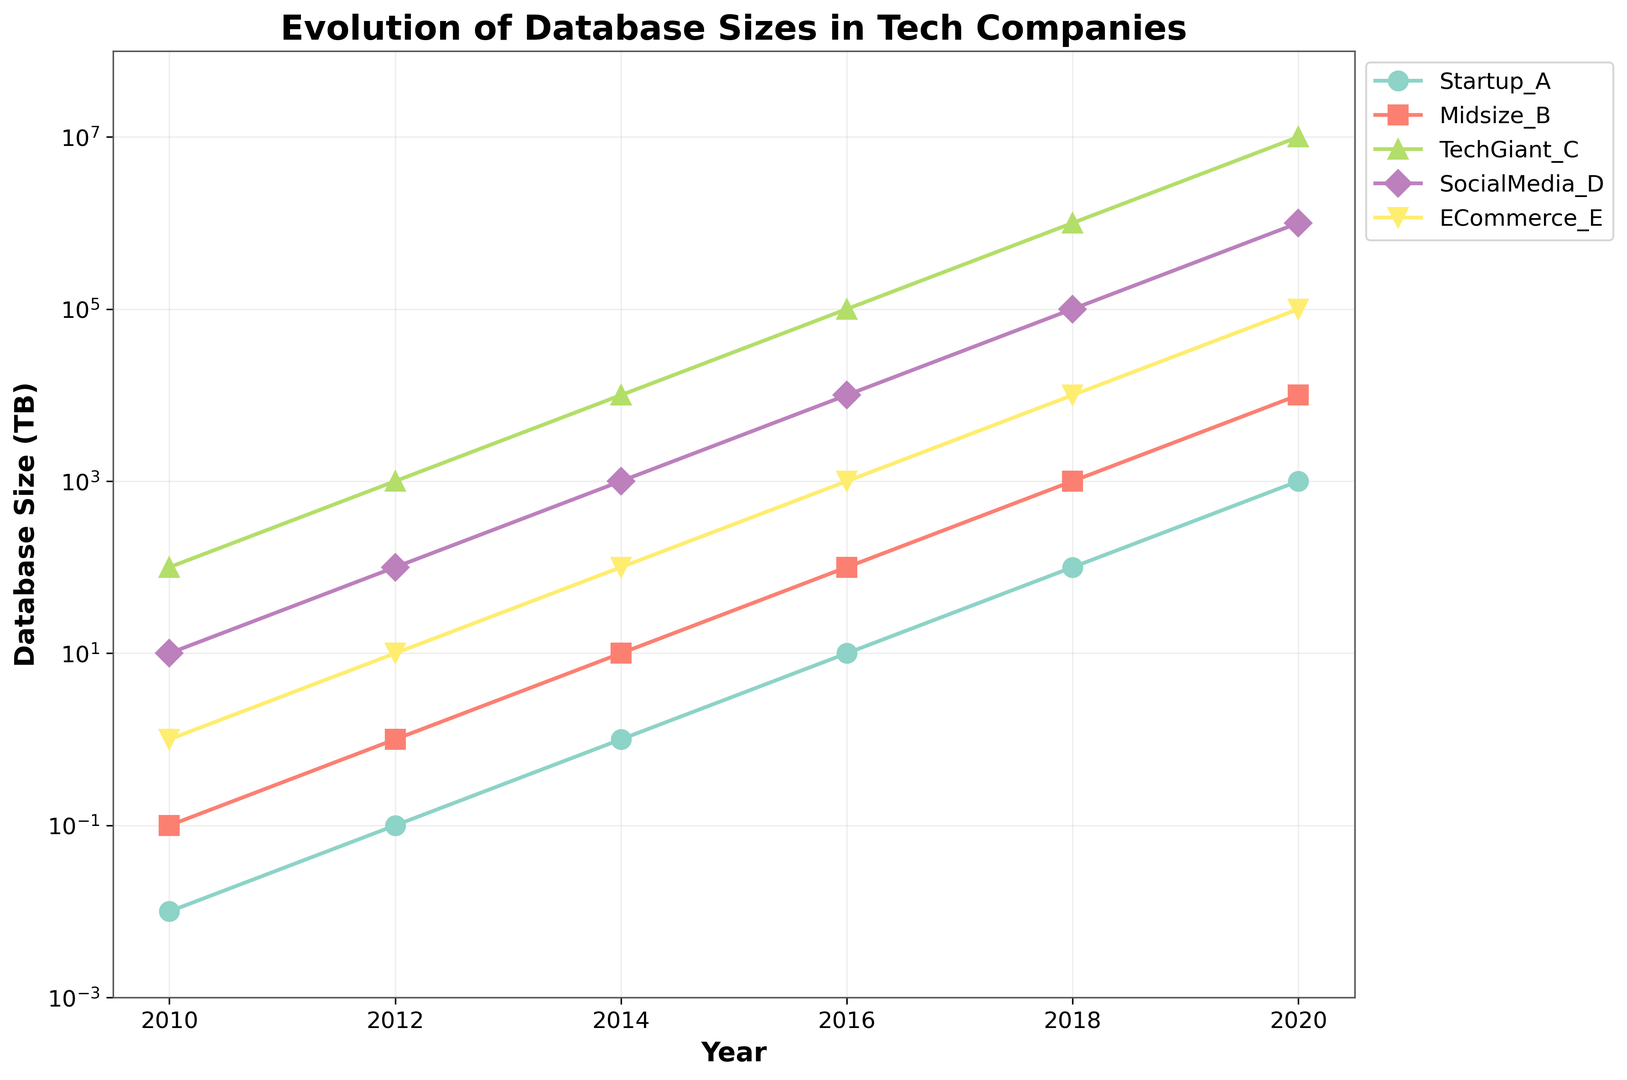Which company had the smallest database size in 2010? The figure shows that in 2010, Startup_A had a database size of 0.01 TB, which is the smallest value for that year compared to other companies.
Answer: Startup_A Which company's database size grew the fastest from 2010 to 2020? By looking at the figure, TechGiant_C's database size grew from 100 TB in 2010 to 10,000,000 TB in 2020. This exponential growth is visually the steepest among all companies.
Answer: TechGiant_C In which year did ECommerce_E reach a database size of 10,000 TB? The figure shows that in 2018, ECommerce_E reached a database size of 10,000 TB.
Answer: 2018 How many companies had a database size of 1,000 TB or more by 2016? According to the figure, by 2016, TechGiant_C, SocialMedia_D, and Midsize_B all had database sizes of 1,000 TB or more.
Answer: 3 Which company maintained a tenfold increase in database size every two years from 2010 to 2020? Startup_A's database size increased tenfold every two years from 0.01 TB in 2010 to 1,000 TB in 2020, as shown in the figure.
Answer: Startup_A Compare the database sizes of SocialMedia_D and TechGiant_C in 2014. Which one was larger and by how much? In 2014, the figure shows SocialMedia_D had 1,000 TB and TechGiant_C had 10,000 TB. The difference is 10,000 - 1,000 = 9,000 TB.
Answer: TechGiant_C, by 9,000 TB What is the overall trend in the database sizes of the tech companies shown in the figure? All companies displayed an exponential growth in their database sizes over the years, as depicted by the upward curves on the logscale chart.
Answer: Exponential growth Between 2012 and 2018, how many times did Midsize_B's database size increase? The figure shows Midsize_B grew from 1 TB in 2012 to 1,000 TB in 2018. This is a 1,000-fold increase (1 to 10 in 2014, 10 to 100 in 2016, and 100 to 1,000 in 2018).
Answer: 1,000 times Which company had the largest database size in 2020, and what was its value? The figure shows that in 2020, TechGiant_C had the largest database size at 10,000,000 TB.
Answer: TechGiant_C, 10,000,000 TB 